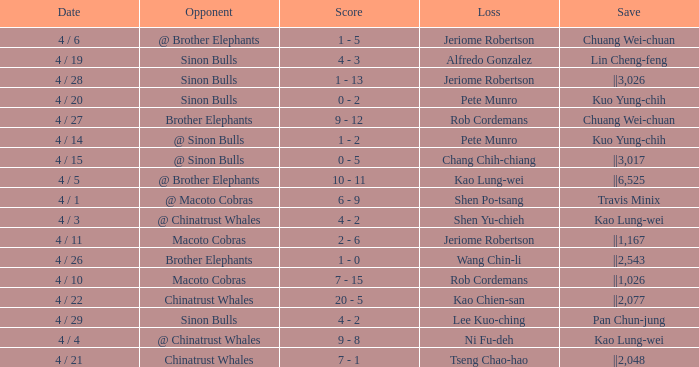Who earned the save in the game against the Sinon Bulls when Jeriome Robertson took the loss? ||3,026. 